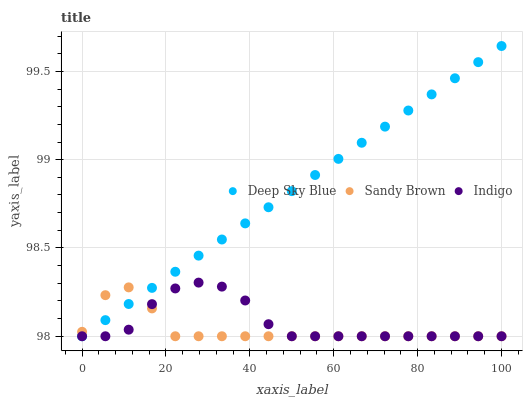Does Sandy Brown have the minimum area under the curve?
Answer yes or no. Yes. Does Deep Sky Blue have the maximum area under the curve?
Answer yes or no. Yes. Does Deep Sky Blue have the minimum area under the curve?
Answer yes or no. No. Does Sandy Brown have the maximum area under the curve?
Answer yes or no. No. Is Deep Sky Blue the smoothest?
Answer yes or no. Yes. Is Indigo the roughest?
Answer yes or no. Yes. Is Sandy Brown the smoothest?
Answer yes or no. No. Is Sandy Brown the roughest?
Answer yes or no. No. Does Indigo have the lowest value?
Answer yes or no. Yes. Does Deep Sky Blue have the highest value?
Answer yes or no. Yes. Does Sandy Brown have the highest value?
Answer yes or no. No. Does Sandy Brown intersect Deep Sky Blue?
Answer yes or no. Yes. Is Sandy Brown less than Deep Sky Blue?
Answer yes or no. No. Is Sandy Brown greater than Deep Sky Blue?
Answer yes or no. No. 